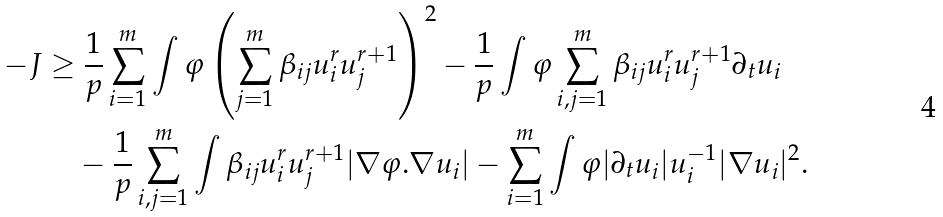<formula> <loc_0><loc_0><loc_500><loc_500>- J \geq & \ \frac { 1 } { p } \sum _ { i = 1 } ^ { m } \int \varphi \left ( \sum _ { j = 1 } ^ { m } \beta _ { i j } u _ { i } ^ { r } u _ { j } ^ { r + 1 } \right ) ^ { 2 } - \frac { 1 } { p } \int \varphi \sum _ { i , j = 1 } ^ { m } \beta _ { i j } u _ { i } ^ { r } u _ { j } ^ { r + 1 } \partial _ { t } u _ { i } \\ & - \frac { 1 } { p } \sum _ { i , j = 1 } ^ { m } \int \beta _ { i j } u _ { i } ^ { r } u _ { j } ^ { r + 1 } | \nabla \varphi . \nabla u _ { i } | - \sum _ { i = 1 } ^ { m } \int \varphi | \partial _ { t } u _ { i } | u _ { i } ^ { - 1 } | \nabla u _ { i } | ^ { 2 } .</formula> 